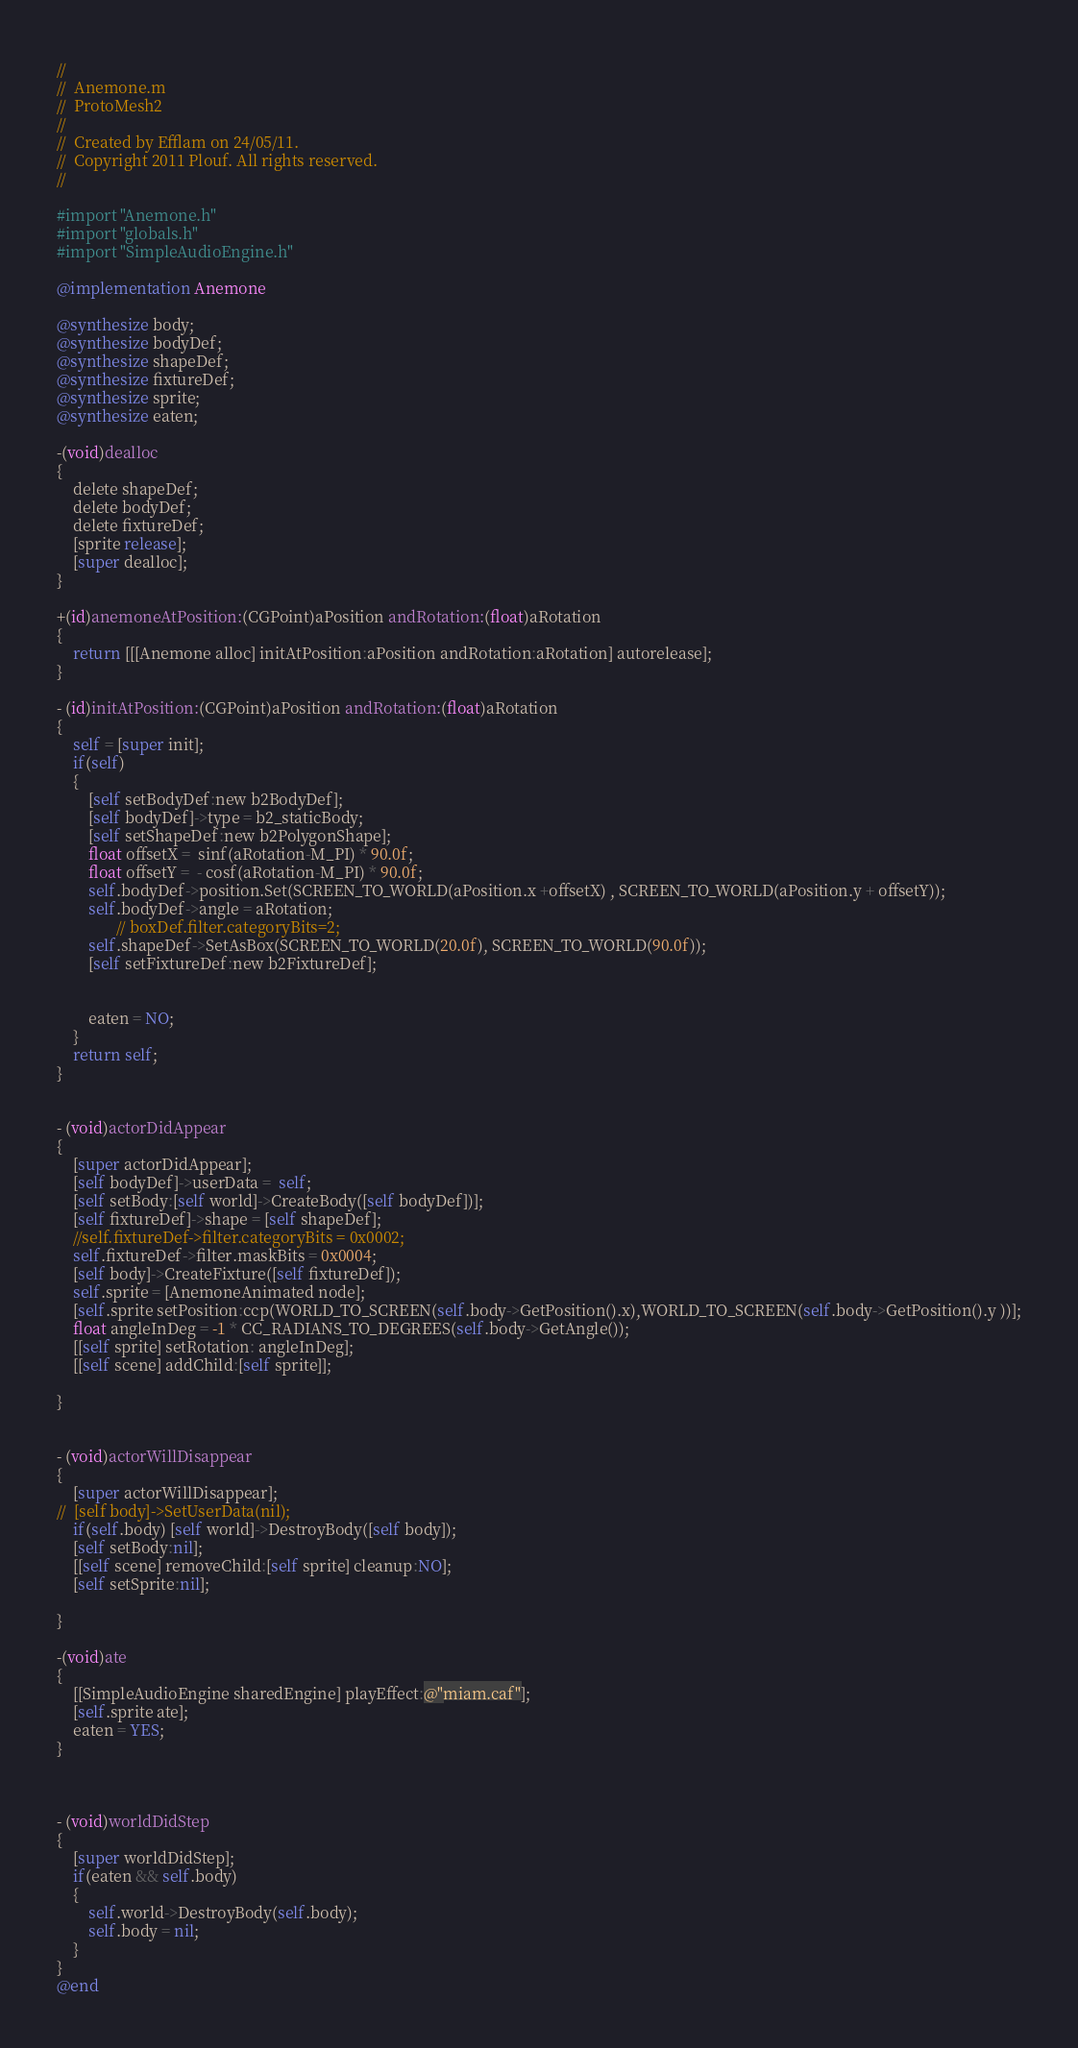Convert code to text. <code><loc_0><loc_0><loc_500><loc_500><_ObjectiveC_>//
//  Anemone.m
//  ProtoMesh2
//
//  Created by Efflam on 24/05/11.
//  Copyright 2011 Plouf. All rights reserved.
//

#import "Anemone.h"
#import "globals.h"
#import "SimpleAudioEngine.h"

@implementation Anemone

@synthesize body;
@synthesize bodyDef;
@synthesize shapeDef;
@synthesize fixtureDef;
@synthesize sprite;
@synthesize eaten;

-(void)dealloc
{
    delete shapeDef;
    delete bodyDef;
    delete fixtureDef;
    [sprite release];
    [super dealloc];
}

+(id)anemoneAtPosition:(CGPoint)aPosition andRotation:(float)aRotation
{
    return [[[Anemone alloc] initAtPosition:aPosition andRotation:aRotation] autorelease];
}

- (id)initAtPosition:(CGPoint)aPosition andRotation:(float)aRotation
{
	self = [super init];
    if(self)
    {
		[self setBodyDef:new b2BodyDef];
        [self bodyDef]->type = b2_staticBody;
		[self setShapeDef:new b2PolygonShape];
        float offsetX =  sinf(aRotation-M_PI) * 90.0f;
        float offsetY =  - cosf(aRotation-M_PI) * 90.0f;
        self.bodyDef->position.Set(SCREEN_TO_WORLD(aPosition.x +offsetX) , SCREEN_TO_WORLD(aPosition.y + offsetY));
        self.bodyDef->angle = aRotation;
               // boxDef.filter.categoryBits=2;
        self.shapeDef->SetAsBox(SCREEN_TO_WORLD(20.0f), SCREEN_TO_WORLD(90.0f));
        [self setFixtureDef:new b2FixtureDef];
        

        eaten = NO;
	}
	return self;
}


- (void)actorDidAppear 
{	
	[super actorDidAppear];
	[self bodyDef]->userData =  self;
	[self setBody:[self world]->CreateBody([self bodyDef])];
	[self fixtureDef]->shape = [self shapeDef];
    //self.fixtureDef->filter.categoryBits = 0x0002;
    self.fixtureDef->filter.maskBits = 0x0004;
    [self body]->CreateFixture([self fixtureDef]);
    self.sprite = [AnemoneAnimated node];
    [self.sprite setPosition:ccp(WORLD_TO_SCREEN(self.body->GetPosition().x),WORLD_TO_SCREEN(self.body->GetPosition().y ))];
    float angleInDeg = -1 * CC_RADIANS_TO_DEGREES(self.body->GetAngle());
    [[self sprite] setRotation: angleInDeg];
	[[self scene] addChild:[self sprite]];
	
}


- (void)actorWillDisappear 
{
    [super actorWillDisappear];
//	[self body]->SetUserData(nil);
	if(self.body) [self world]->DestroyBody([self body]);
	[self setBody:nil];
	[[self scene] removeChild:[self sprite] cleanup:NO];
    [self setSprite:nil];
	
}

-(void)ate
{
    [[SimpleAudioEngine sharedEngine] playEffect:@"miam.caf"];
    [self.sprite ate];
    eaten = YES;
}



- (void)worldDidStep 
{
	[super worldDidStep];
    if(eaten && self.body)
    {
        self.world->DestroyBody(self.body);
        self.body = nil;
    }
}
@end
</code> 